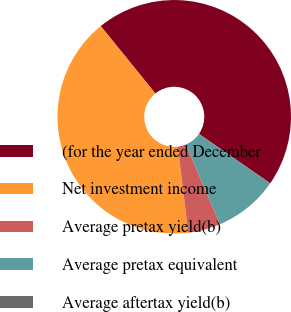Convert chart to OTSL. <chart><loc_0><loc_0><loc_500><loc_500><pie_chart><fcel>(for the year ended December<fcel>Net investment income<fcel>Average pretax yield(b)<fcel>Average pretax equivalent<fcel>Average aftertax yield(b)<nl><fcel>45.47%<fcel>41.08%<fcel>4.48%<fcel>8.88%<fcel>0.09%<nl></chart> 